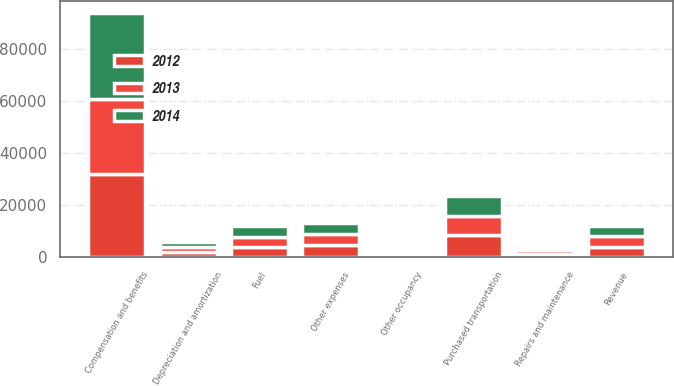Convert chart. <chart><loc_0><loc_0><loc_500><loc_500><stacked_bar_chart><ecel><fcel>Revenue<fcel>Compensation and benefits<fcel>Repairs and maintenance<fcel>Depreciation and amortization<fcel>Purchased transportation<fcel>Fuel<fcel>Other occupancy<fcel>Other expenses<nl><fcel>2012<fcel>4027<fcel>32045<fcel>1371<fcel>1923<fcel>8460<fcel>3883<fcel>1044<fcel>4538<nl><fcel>2013<fcel>4027<fcel>28557<fcel>1240<fcel>1867<fcel>7486<fcel>4027<fcel>950<fcel>4277<nl><fcel>2014<fcel>4027<fcel>33102<fcel>1228<fcel>1858<fcel>7354<fcel>4090<fcel>902<fcel>4250<nl></chart> 